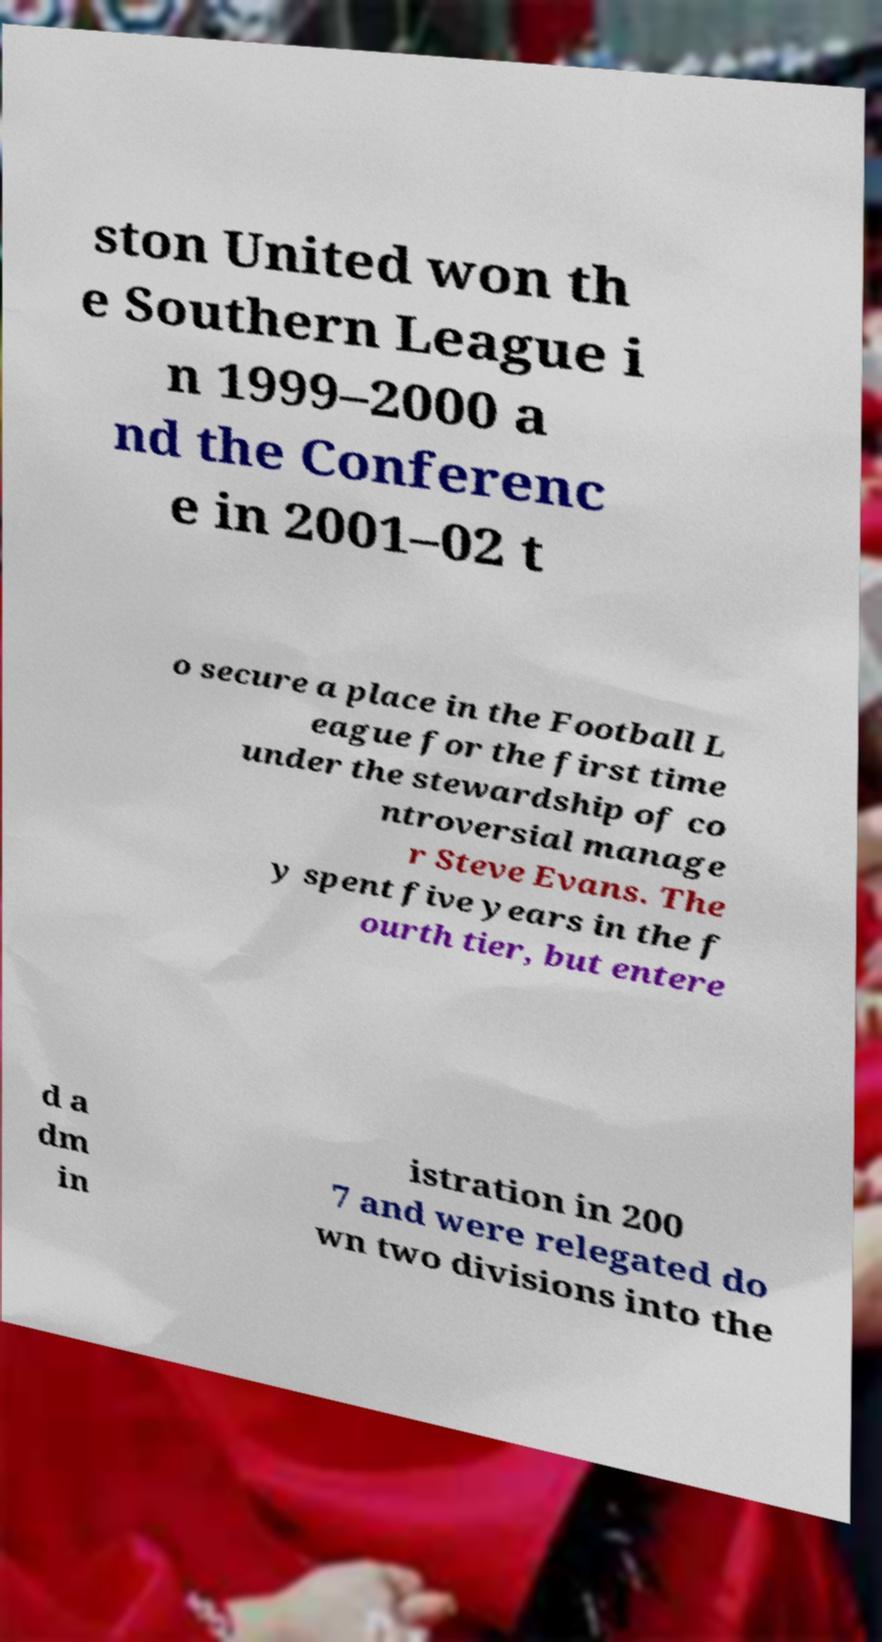What messages or text are displayed in this image? I need them in a readable, typed format. ston United won th e Southern League i n 1999–2000 a nd the Conferenc e in 2001–02 t o secure a place in the Football L eague for the first time under the stewardship of co ntroversial manage r Steve Evans. The y spent five years in the f ourth tier, but entere d a dm in istration in 200 7 and were relegated do wn two divisions into the 